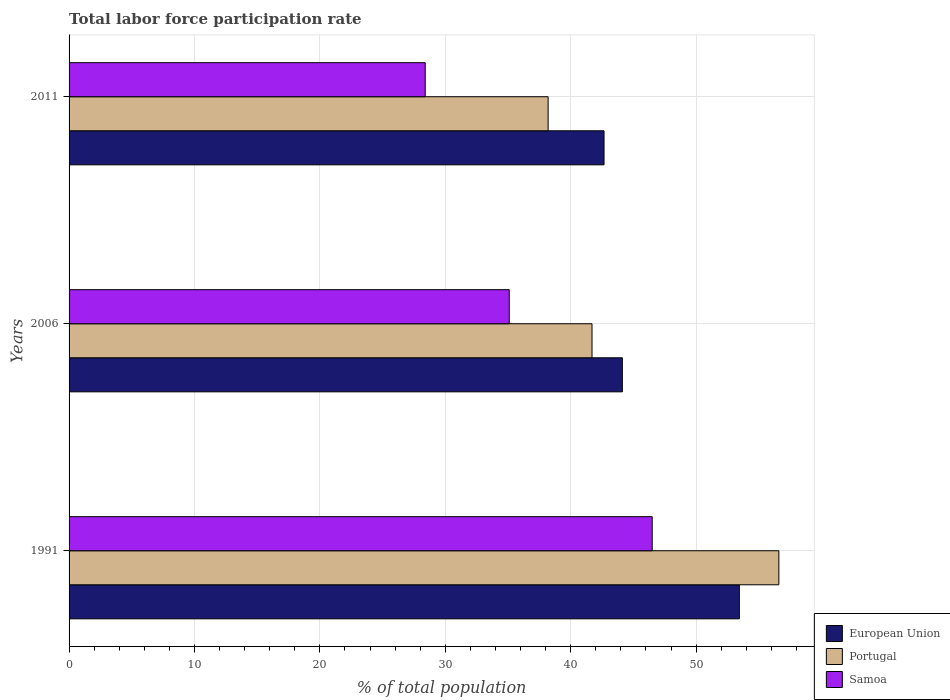Are the number of bars on each tick of the Y-axis equal?
Your answer should be very brief. Yes. What is the label of the 2nd group of bars from the top?
Offer a terse response. 2006. What is the total labor force participation rate in Portugal in 2011?
Keep it short and to the point. 38.2. Across all years, what is the maximum total labor force participation rate in Samoa?
Your answer should be very brief. 46.5. Across all years, what is the minimum total labor force participation rate in Portugal?
Ensure brevity in your answer.  38.2. In which year was the total labor force participation rate in Samoa minimum?
Your answer should be very brief. 2011. What is the total total labor force participation rate in Samoa in the graph?
Make the answer very short. 110. What is the difference between the total labor force participation rate in European Union in 1991 and that in 2011?
Your response must be concise. 10.79. What is the difference between the total labor force participation rate in Samoa in 2006 and the total labor force participation rate in Portugal in 2011?
Make the answer very short. -3.1. What is the average total labor force participation rate in European Union per year?
Make the answer very short. 46.74. In the year 2011, what is the difference between the total labor force participation rate in Portugal and total labor force participation rate in European Union?
Your response must be concise. -4.46. What is the ratio of the total labor force participation rate in Samoa in 1991 to that in 2006?
Offer a very short reply. 1.32. Is the difference between the total labor force participation rate in Portugal in 1991 and 2011 greater than the difference between the total labor force participation rate in European Union in 1991 and 2011?
Keep it short and to the point. Yes. What is the difference between the highest and the second highest total labor force participation rate in Samoa?
Give a very brief answer. 11.4. What is the difference between the highest and the lowest total labor force participation rate in Portugal?
Make the answer very short. 18.4. What does the 2nd bar from the top in 1991 represents?
Keep it short and to the point. Portugal. How many bars are there?
Your answer should be compact. 9. Are all the bars in the graph horizontal?
Offer a terse response. Yes. How many years are there in the graph?
Your response must be concise. 3. What is the difference between two consecutive major ticks on the X-axis?
Your answer should be very brief. 10. Does the graph contain any zero values?
Ensure brevity in your answer.  No. How many legend labels are there?
Keep it short and to the point. 3. What is the title of the graph?
Your response must be concise. Total labor force participation rate. Does "Belize" appear as one of the legend labels in the graph?
Offer a terse response. No. What is the label or title of the X-axis?
Give a very brief answer. % of total population. What is the label or title of the Y-axis?
Keep it short and to the point. Years. What is the % of total population of European Union in 1991?
Give a very brief answer. 53.45. What is the % of total population of Portugal in 1991?
Offer a very short reply. 56.6. What is the % of total population of Samoa in 1991?
Keep it short and to the point. 46.5. What is the % of total population of European Union in 2006?
Make the answer very short. 44.12. What is the % of total population of Portugal in 2006?
Offer a very short reply. 41.7. What is the % of total population of Samoa in 2006?
Your answer should be very brief. 35.1. What is the % of total population of European Union in 2011?
Keep it short and to the point. 42.66. What is the % of total population in Portugal in 2011?
Make the answer very short. 38.2. What is the % of total population in Samoa in 2011?
Your answer should be very brief. 28.4. Across all years, what is the maximum % of total population in European Union?
Offer a very short reply. 53.45. Across all years, what is the maximum % of total population in Portugal?
Ensure brevity in your answer.  56.6. Across all years, what is the maximum % of total population of Samoa?
Make the answer very short. 46.5. Across all years, what is the minimum % of total population in European Union?
Your answer should be very brief. 42.66. Across all years, what is the minimum % of total population of Portugal?
Your answer should be very brief. 38.2. Across all years, what is the minimum % of total population in Samoa?
Provide a short and direct response. 28.4. What is the total % of total population in European Union in the graph?
Give a very brief answer. 140.23. What is the total % of total population in Portugal in the graph?
Offer a terse response. 136.5. What is the total % of total population in Samoa in the graph?
Your answer should be compact. 110. What is the difference between the % of total population in European Union in 1991 and that in 2006?
Keep it short and to the point. 9.33. What is the difference between the % of total population in Portugal in 1991 and that in 2006?
Provide a succinct answer. 14.9. What is the difference between the % of total population in European Union in 1991 and that in 2011?
Your response must be concise. 10.79. What is the difference between the % of total population of Portugal in 1991 and that in 2011?
Your answer should be compact. 18.4. What is the difference between the % of total population in European Union in 2006 and that in 2011?
Make the answer very short. 1.46. What is the difference between the % of total population in Portugal in 2006 and that in 2011?
Ensure brevity in your answer.  3.5. What is the difference between the % of total population in Samoa in 2006 and that in 2011?
Give a very brief answer. 6.7. What is the difference between the % of total population in European Union in 1991 and the % of total population in Portugal in 2006?
Your answer should be very brief. 11.75. What is the difference between the % of total population of European Union in 1991 and the % of total population of Samoa in 2006?
Ensure brevity in your answer.  18.35. What is the difference between the % of total population of Portugal in 1991 and the % of total population of Samoa in 2006?
Your answer should be very brief. 21.5. What is the difference between the % of total population of European Union in 1991 and the % of total population of Portugal in 2011?
Your answer should be compact. 15.25. What is the difference between the % of total population in European Union in 1991 and the % of total population in Samoa in 2011?
Provide a short and direct response. 25.05. What is the difference between the % of total population of Portugal in 1991 and the % of total population of Samoa in 2011?
Ensure brevity in your answer.  28.2. What is the difference between the % of total population of European Union in 2006 and the % of total population of Portugal in 2011?
Your answer should be very brief. 5.92. What is the difference between the % of total population of European Union in 2006 and the % of total population of Samoa in 2011?
Provide a short and direct response. 15.72. What is the average % of total population of European Union per year?
Your response must be concise. 46.74. What is the average % of total population in Portugal per year?
Keep it short and to the point. 45.5. What is the average % of total population of Samoa per year?
Keep it short and to the point. 36.67. In the year 1991, what is the difference between the % of total population in European Union and % of total population in Portugal?
Give a very brief answer. -3.15. In the year 1991, what is the difference between the % of total population in European Union and % of total population in Samoa?
Provide a short and direct response. 6.95. In the year 1991, what is the difference between the % of total population of Portugal and % of total population of Samoa?
Give a very brief answer. 10.1. In the year 2006, what is the difference between the % of total population in European Union and % of total population in Portugal?
Your response must be concise. 2.42. In the year 2006, what is the difference between the % of total population of European Union and % of total population of Samoa?
Offer a terse response. 9.02. In the year 2011, what is the difference between the % of total population in European Union and % of total population in Portugal?
Ensure brevity in your answer.  4.46. In the year 2011, what is the difference between the % of total population of European Union and % of total population of Samoa?
Provide a succinct answer. 14.26. In the year 2011, what is the difference between the % of total population of Portugal and % of total population of Samoa?
Give a very brief answer. 9.8. What is the ratio of the % of total population in European Union in 1991 to that in 2006?
Offer a terse response. 1.21. What is the ratio of the % of total population in Portugal in 1991 to that in 2006?
Provide a succinct answer. 1.36. What is the ratio of the % of total population of Samoa in 1991 to that in 2006?
Offer a very short reply. 1.32. What is the ratio of the % of total population of European Union in 1991 to that in 2011?
Give a very brief answer. 1.25. What is the ratio of the % of total population of Portugal in 1991 to that in 2011?
Provide a succinct answer. 1.48. What is the ratio of the % of total population in Samoa in 1991 to that in 2011?
Ensure brevity in your answer.  1.64. What is the ratio of the % of total population in European Union in 2006 to that in 2011?
Provide a succinct answer. 1.03. What is the ratio of the % of total population in Portugal in 2006 to that in 2011?
Your response must be concise. 1.09. What is the ratio of the % of total population in Samoa in 2006 to that in 2011?
Provide a short and direct response. 1.24. What is the difference between the highest and the second highest % of total population of European Union?
Make the answer very short. 9.33. What is the difference between the highest and the second highest % of total population in Portugal?
Offer a terse response. 14.9. What is the difference between the highest and the second highest % of total population in Samoa?
Provide a succinct answer. 11.4. What is the difference between the highest and the lowest % of total population of European Union?
Give a very brief answer. 10.79. 